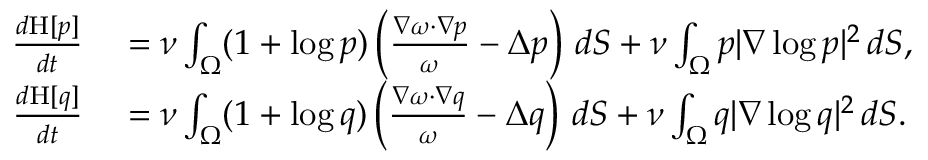Convert formula to latex. <formula><loc_0><loc_0><loc_500><loc_500>\begin{array} { r l } { \frac { d H [ p ] } { d t } } & = \nu \int _ { \Omega } ( 1 + \log p ) \left ( \frac { \nabla \omega \cdot \nabla p } { \omega } - \Delta p \right ) \, d S + \nu \int _ { \Omega } p | \nabla \log p | ^ { 2 } \, d S , } \\ { \frac { d H [ q ] } { d t } } & = \nu \int _ { \Omega } ( 1 + \log q ) \left ( \frac { \nabla \omega \cdot \nabla q } { \omega } - \Delta q \right ) \, d S + \nu \int _ { \Omega } q | \nabla \log q | ^ { 2 } \, d S . } \end{array}</formula> 